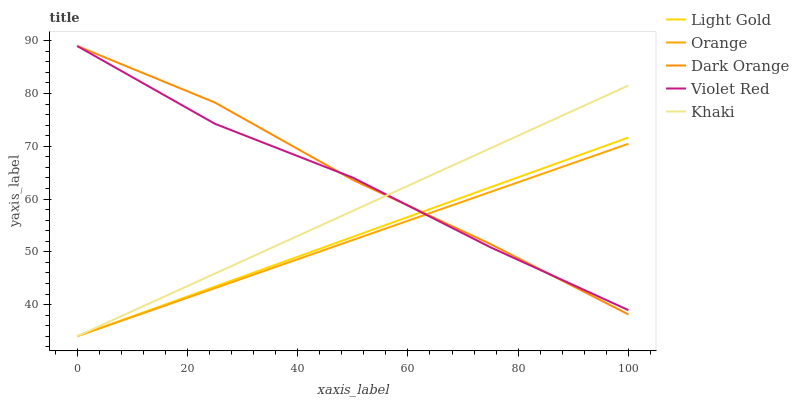Does Orange have the minimum area under the curve?
Answer yes or no. Yes. Does Dark Orange have the maximum area under the curve?
Answer yes or no. Yes. Does Violet Red have the minimum area under the curve?
Answer yes or no. No. Does Violet Red have the maximum area under the curve?
Answer yes or no. No. Is Orange the smoothest?
Answer yes or no. Yes. Is Violet Red the roughest?
Answer yes or no. Yes. Is Dark Orange the smoothest?
Answer yes or no. No. Is Dark Orange the roughest?
Answer yes or no. No. Does Orange have the lowest value?
Answer yes or no. Yes. Does Dark Orange have the lowest value?
Answer yes or no. No. Does Violet Red have the highest value?
Answer yes or no. Yes. Does Khaki have the highest value?
Answer yes or no. No. Does Violet Red intersect Khaki?
Answer yes or no. Yes. Is Violet Red less than Khaki?
Answer yes or no. No. Is Violet Red greater than Khaki?
Answer yes or no. No. 